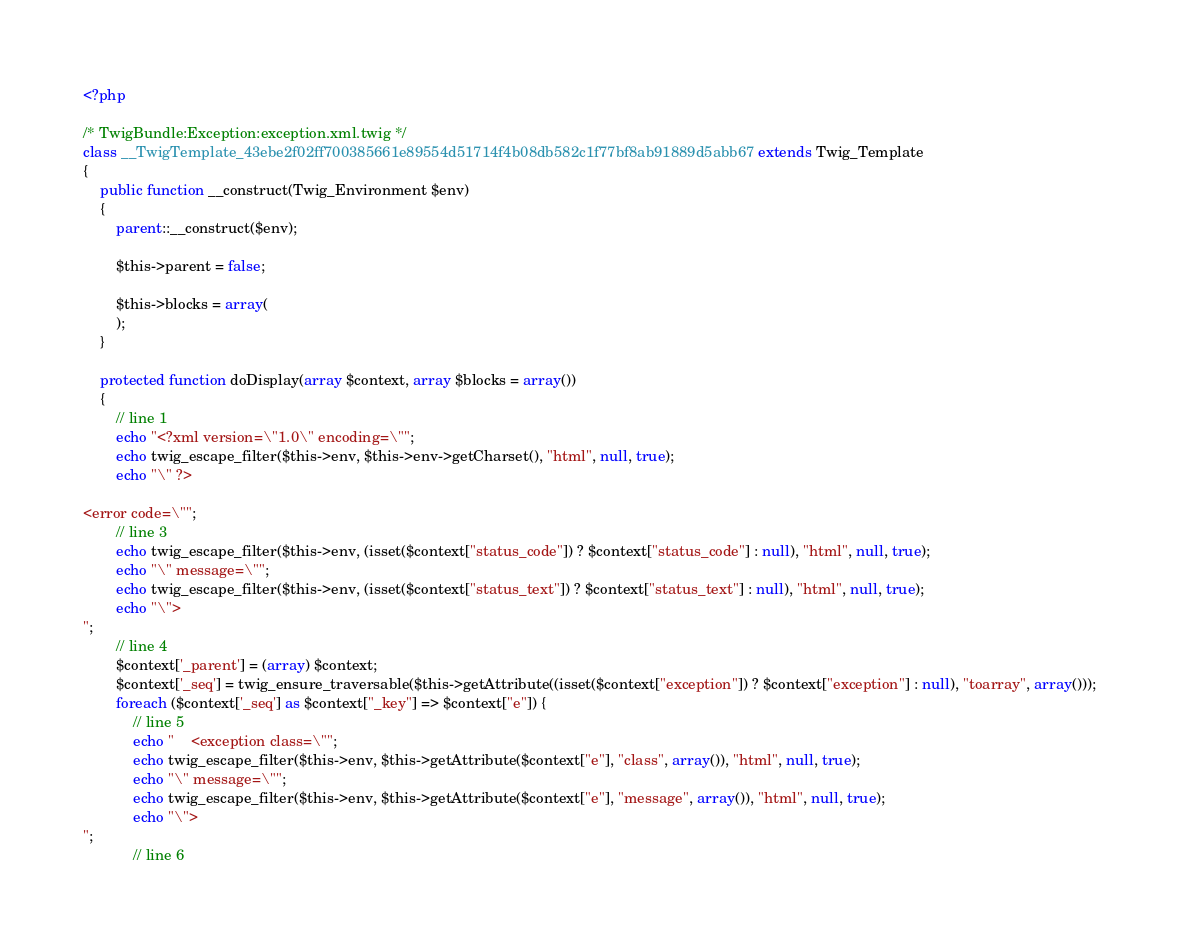<code> <loc_0><loc_0><loc_500><loc_500><_PHP_><?php

/* TwigBundle:Exception:exception.xml.twig */
class __TwigTemplate_43ebe2f02ff700385661e89554d51714f4b08db582c1f77bf8ab91889d5abb67 extends Twig_Template
{
    public function __construct(Twig_Environment $env)
    {
        parent::__construct($env);

        $this->parent = false;

        $this->blocks = array(
        );
    }

    protected function doDisplay(array $context, array $blocks = array())
    {
        // line 1
        echo "<?xml version=\"1.0\" encoding=\"";
        echo twig_escape_filter($this->env, $this->env->getCharset(), "html", null, true);
        echo "\" ?>

<error code=\"";
        // line 3
        echo twig_escape_filter($this->env, (isset($context["status_code"]) ? $context["status_code"] : null), "html", null, true);
        echo "\" message=\"";
        echo twig_escape_filter($this->env, (isset($context["status_text"]) ? $context["status_text"] : null), "html", null, true);
        echo "\">
";
        // line 4
        $context['_parent'] = (array) $context;
        $context['_seq'] = twig_ensure_traversable($this->getAttribute((isset($context["exception"]) ? $context["exception"] : null), "toarray", array()));
        foreach ($context['_seq'] as $context["_key"] => $context["e"]) {
            // line 5
            echo "    <exception class=\"";
            echo twig_escape_filter($this->env, $this->getAttribute($context["e"], "class", array()), "html", null, true);
            echo "\" message=\"";
            echo twig_escape_filter($this->env, $this->getAttribute($context["e"], "message", array()), "html", null, true);
            echo "\">
";
            // line 6</code> 